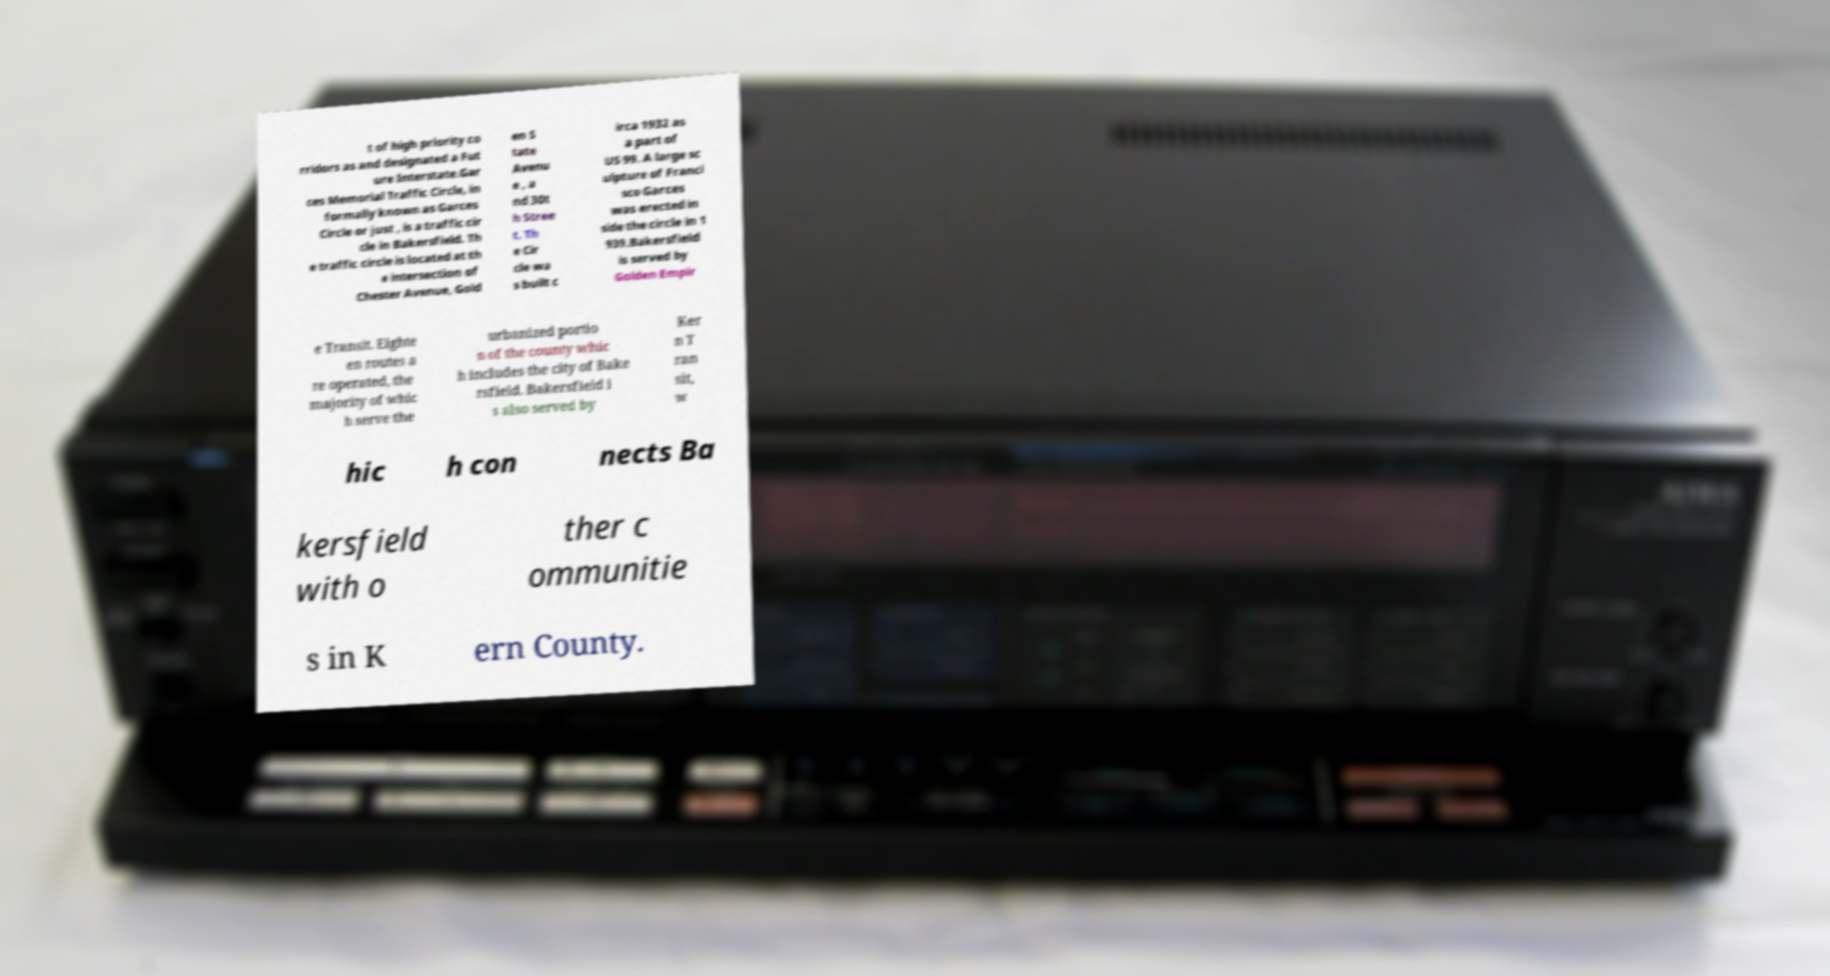I need the written content from this picture converted into text. Can you do that? t of high priority co rridors as and designated a Fut ure Interstate.Gar ces Memorial Traffic Circle, in formally known as Garces Circle or just , is a traffic cir cle in Bakersfield. Th e traffic circle is located at th e intersection of Chester Avenue, Gold en S tate Avenu e , a nd 30t h Stree t. Th e Cir cle wa s built c irca 1932 as a part of US 99. A large sc ulpture of Franci sco Garces was erected in side the circle in 1 939.Bakersfield is served by Golden Empir e Transit. Eighte en routes a re operated, the majority of whic h serve the urbanized portio n of the county whic h includes the city of Bake rsfield. Bakersfield i s also served by Ker n T ran sit, w hic h con nects Ba kersfield with o ther c ommunitie s in K ern County. 